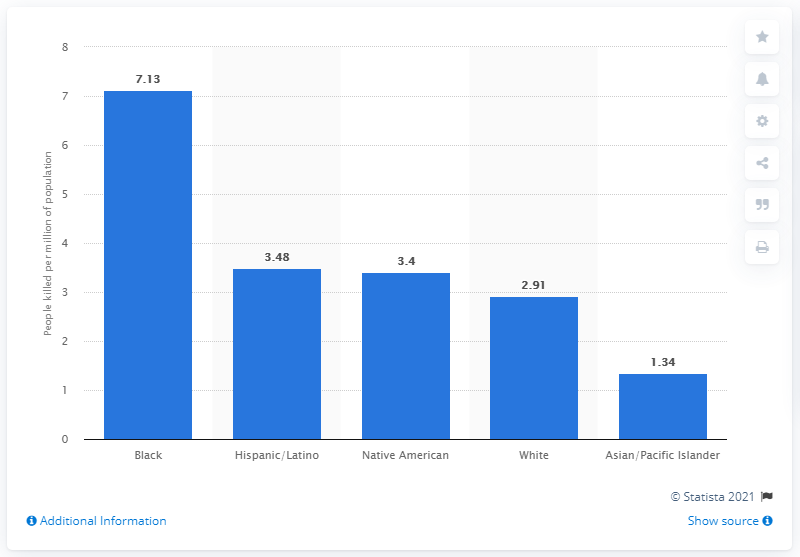Highlight a few significant elements in this photo. In 2015, a total of 7.13 black or African American individuals were killed by U.S. police. 